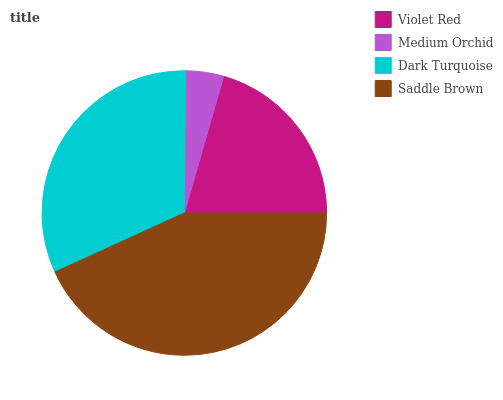Is Medium Orchid the minimum?
Answer yes or no. Yes. Is Saddle Brown the maximum?
Answer yes or no. Yes. Is Dark Turquoise the minimum?
Answer yes or no. No. Is Dark Turquoise the maximum?
Answer yes or no. No. Is Dark Turquoise greater than Medium Orchid?
Answer yes or no. Yes. Is Medium Orchid less than Dark Turquoise?
Answer yes or no. Yes. Is Medium Orchid greater than Dark Turquoise?
Answer yes or no. No. Is Dark Turquoise less than Medium Orchid?
Answer yes or no. No. Is Dark Turquoise the high median?
Answer yes or no. Yes. Is Violet Red the low median?
Answer yes or no. Yes. Is Violet Red the high median?
Answer yes or no. No. Is Saddle Brown the low median?
Answer yes or no. No. 